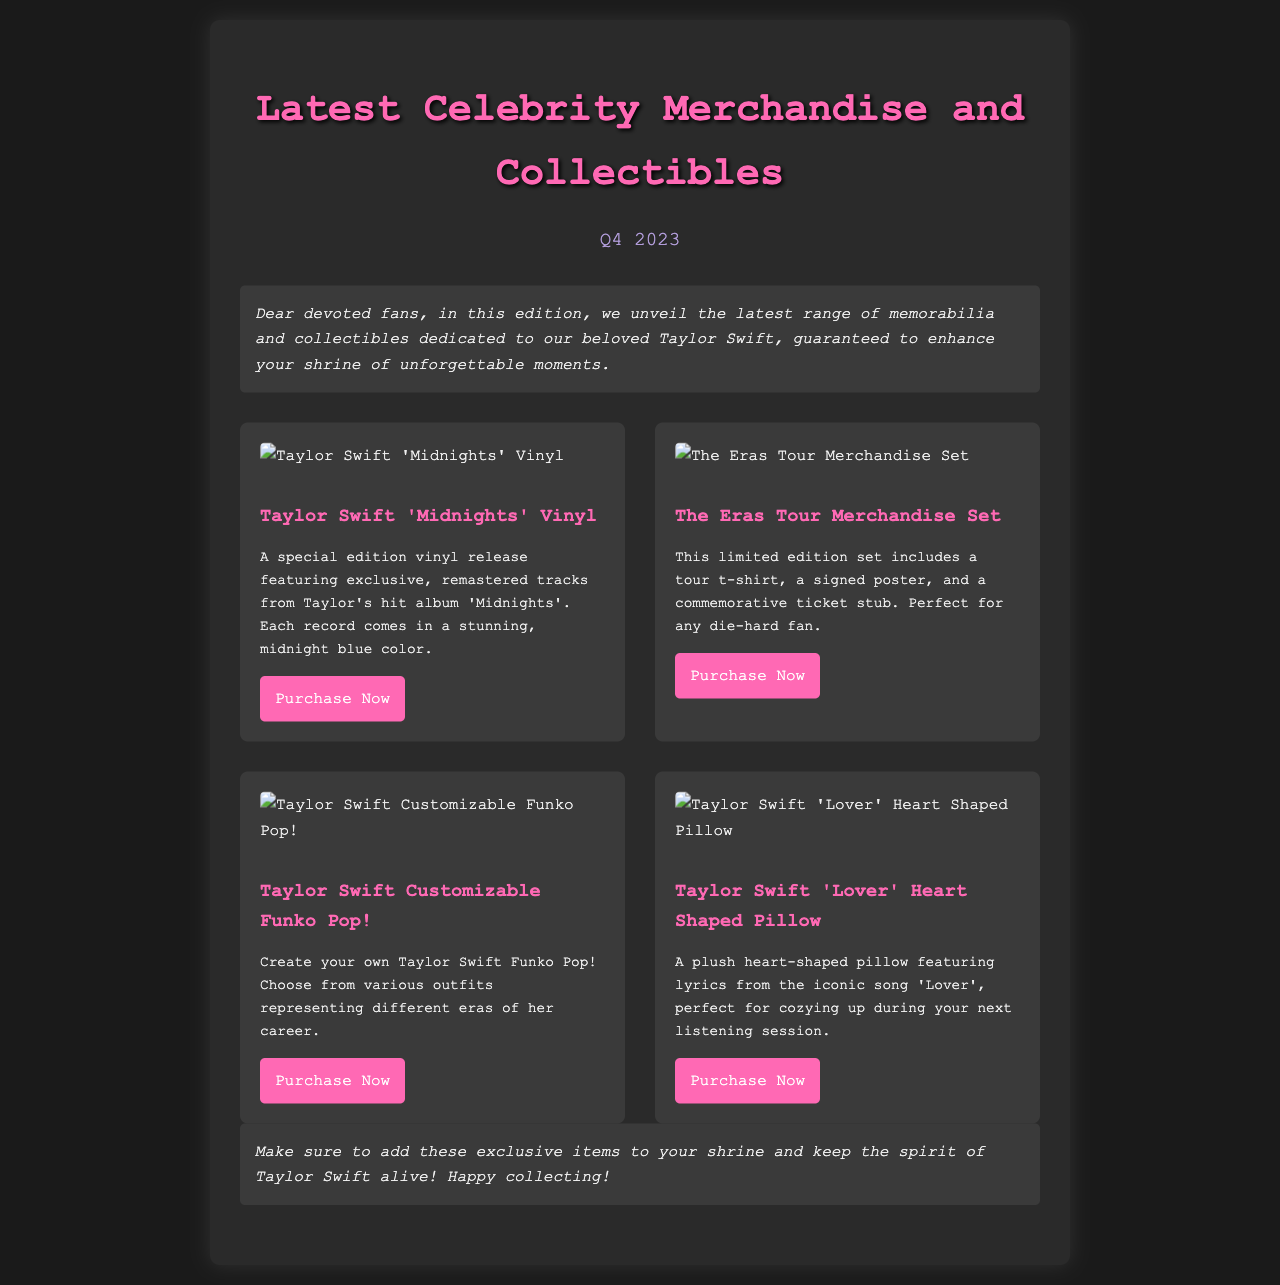What is the title of the newsletter? The title of the newsletter is prominently displayed at the top of the document, reading "Latest Celebrity Merchandise and Collectibles".
Answer: Latest Celebrity Merchandise and Collectibles How many merchandise items are showcased? The merchandise grid displays a total of four distinct items available for fans.
Answer: Four What is the color of the 'Midnights' Vinyl? The description of the 'Midnights' Vinyl mentions that it comes in a stunning, midnight blue color.
Answer: Midnight blue What does the Eras Tour Merchandise Set include? The description lists three specific items included in the set: a tour t-shirt, a signed poster, and a commemorative ticket stub.
Answer: Tour t-shirt, signed poster, commemorative ticket stub What type of merchandise is the 'Lover' Heart Shaped Pillow? The pillow is indicated as plush and is themed around the song 'Lover' which features its lyrics.
Answer: Plush pillow What is a unique feature of the Taylor Swift Customizable Funko Pop!? The description mentions that fans can create their own Funko Pop by choosing outfits from different eras of Taylor's career.
Answer: Customizable outfits What is the primary color theme of the newsletter? The overall color scheme features dark backgrounds with pink accents, such as titles and buttons, which can be observed throughout the document.
Answer: Dark with pink accents What is the main purpose of this newsletter? The newsletter is aimed at informing fans about the latest merchandise and collectibles related to Taylor Swift to enhance their fan experience.
Answer: Inform about merchandise What is the call to action in the newsletter? The newsletter encourages fans to add exclusive items to their collection by providing purchase links for each merchandise item.
Answer: Add to your shrine and purchase items 